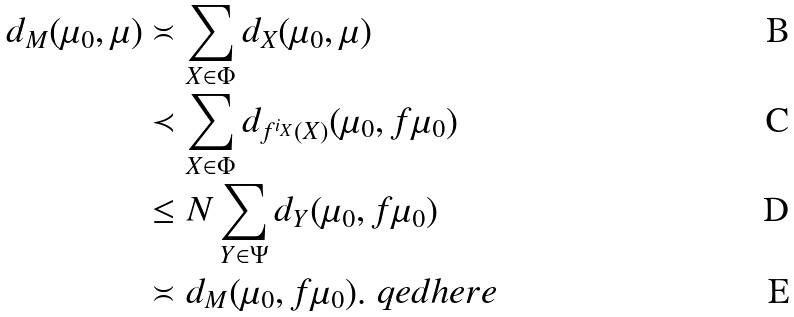Convert formula to latex. <formula><loc_0><loc_0><loc_500><loc_500>d _ { M } ( \mu _ { 0 } , \mu ) & \asymp \sum _ { X \in \Phi } d _ { X } ( \mu _ { 0 } , \mu ) \\ & \prec \sum _ { X \in \Phi } d _ { f ^ { i _ { X } } ( X ) } ( \mu _ { 0 } , f \mu _ { 0 } ) \\ & \leq N \sum _ { Y \in \Psi } d _ { Y } ( \mu _ { 0 } , f \mu _ { 0 } ) \\ & \asymp d _ { M } ( \mu _ { 0 } , f \mu _ { 0 } ) . \ q e d h e r e</formula> 